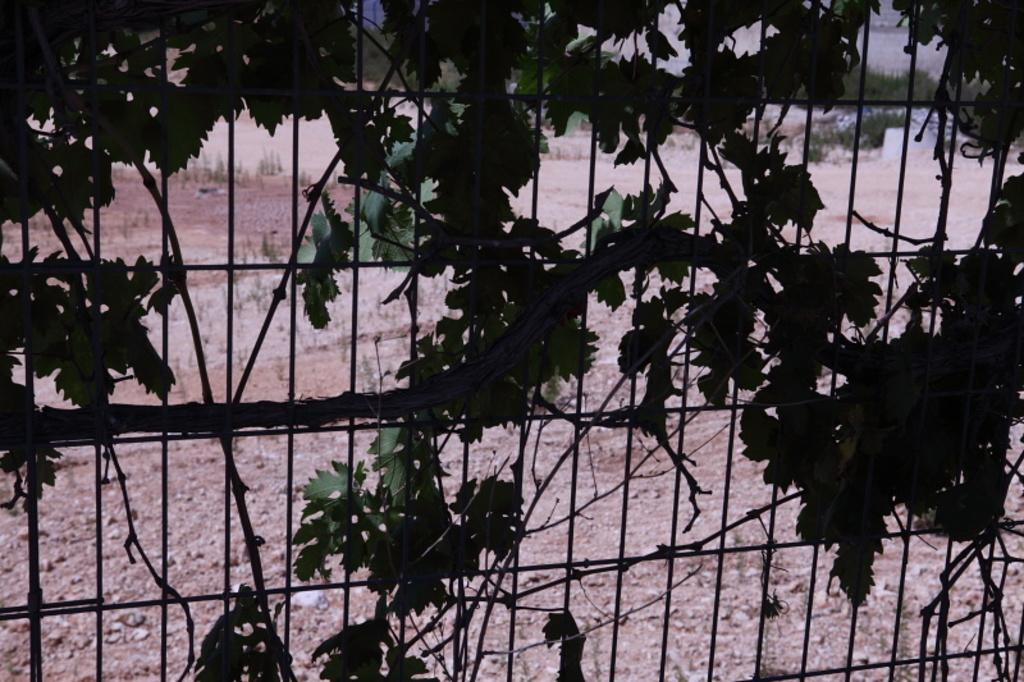What type of vegetation is near the railing in the image? There are bushes near the railing in the image. What can be seen in the background of the image? The ground and plants are visible in the background of the image. What type of coil is present in the image? There is no coil present in the image. What is the condition of the minister in the image? There is no minister present in the image. 